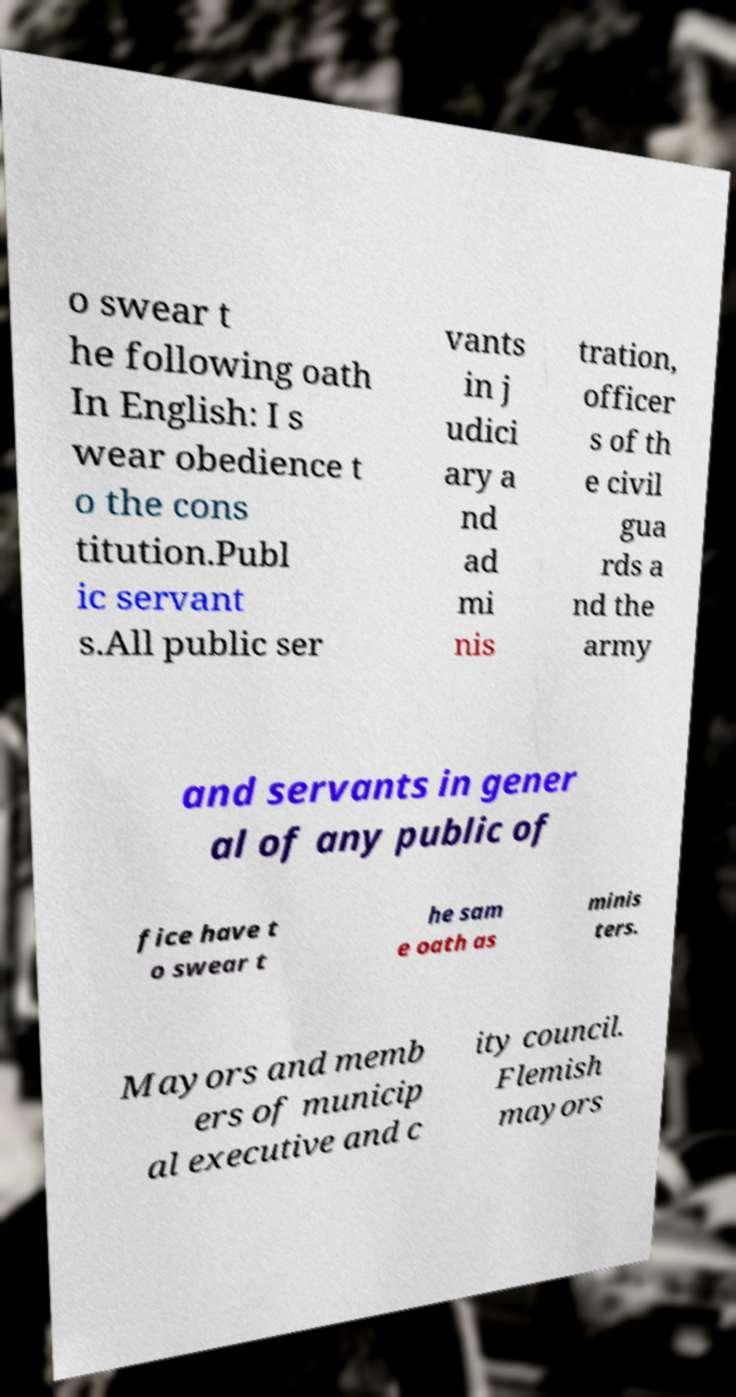There's text embedded in this image that I need extracted. Can you transcribe it verbatim? o swear t he following oath In English: I s wear obedience t o the cons titution.Publ ic servant s.All public ser vants in j udici ary a nd ad mi nis tration, officer s of th e civil gua rds a nd the army and servants in gener al of any public of fice have t o swear t he sam e oath as minis ters. Mayors and memb ers of municip al executive and c ity council. Flemish mayors 